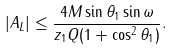<formula> <loc_0><loc_0><loc_500><loc_500>| A _ { L } | \leq \frac { 4 M \sin \theta _ { 1 } \sin \omega } { z _ { 1 } Q ( 1 + \cos ^ { 2 } \theta _ { 1 } ) } .</formula> 